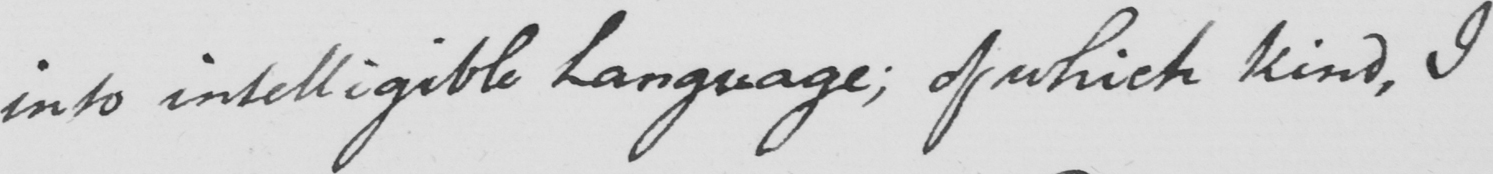What text is written in this handwritten line? into intelligible Language ; of which kind , I 